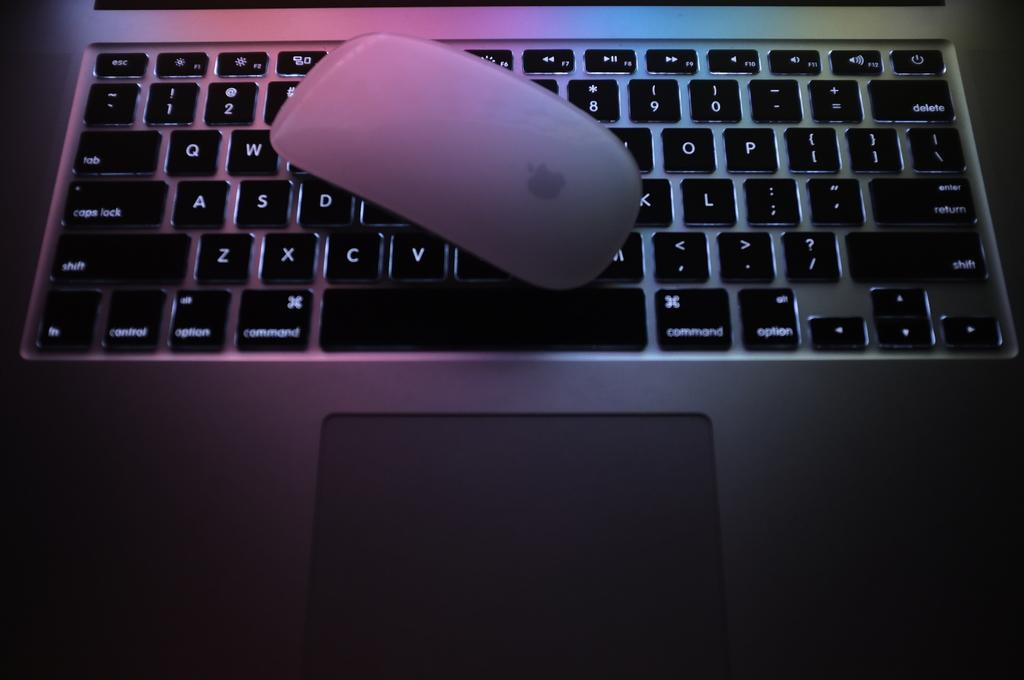<image>
Describe the image concisely. A mouse sits on an open laptop above the letter V. 